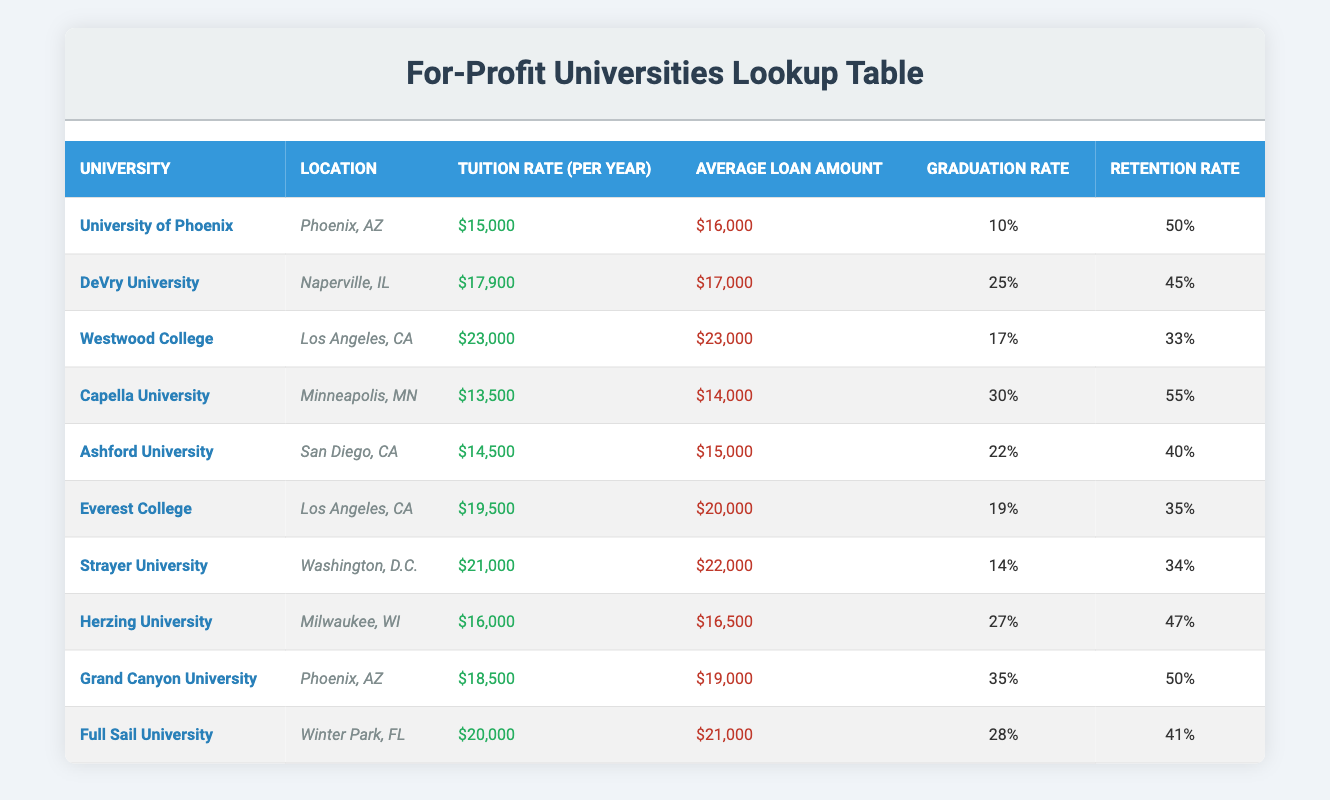What is the tuition rate for Capella University? The table lists the tuition rate for Capella University as $13,500 per year.
Answer: $13,500 Which university has the highest graduation rate? By examining the graduation rates in the table, Grand Canyon University has the highest graduation rate at 35%.
Answer: Grand Canyon University What is the difference between the average loan amounts for Westwood College and DeVry University? The average loan amount for Westwood College is $23,000, and for DeVry University, it is $17,000. The difference is calculated as $23,000 - $17,000 = $6,000.
Answer: $6,000 Is the retention rate for Ashford University greater than 40%? The retention rate for Ashford University is 40%, which means it is not greater than 40%. Thus, the answer is no.
Answer: No What is the average tuition rate of all the universities listed in the table? The tuition rates of the universities are $15,000, $17,900, $23,000, $13,500, $14,500, $19,500, $21,000, $16,000, $18,500, and $20,000. The sum of these values is $189,900, and there are 10 universities, so the average is $189,900 / 10 = $18,990.
Answer: $18,990 Which university located in Phoenix, AZ has a higher average loan amount? The two universities located in Phoenix, AZ are the University of Phoenix with an average loan amount of $16,000 and Grand Canyon University with $19,000. Comparing these amounts shows that Grand Canyon University has a higher average loan amount.
Answer: Grand Canyon University Do both Herzing University and Strayer University have graduation rates below 30%? Both universities have graduation rates of 27% for Herzing University and 14% for Strayer University. Since both rates are below 30%, the answer is yes.
Answer: Yes If you combine the retention rates for University of Phoenix and Grand Canyon University, what would be the total? The retention rates are 50% for the University of Phoenix and 50% for Grand Canyon University. Adding these rates gives a total of 50% + 50% = 100%.
Answer: 100% 